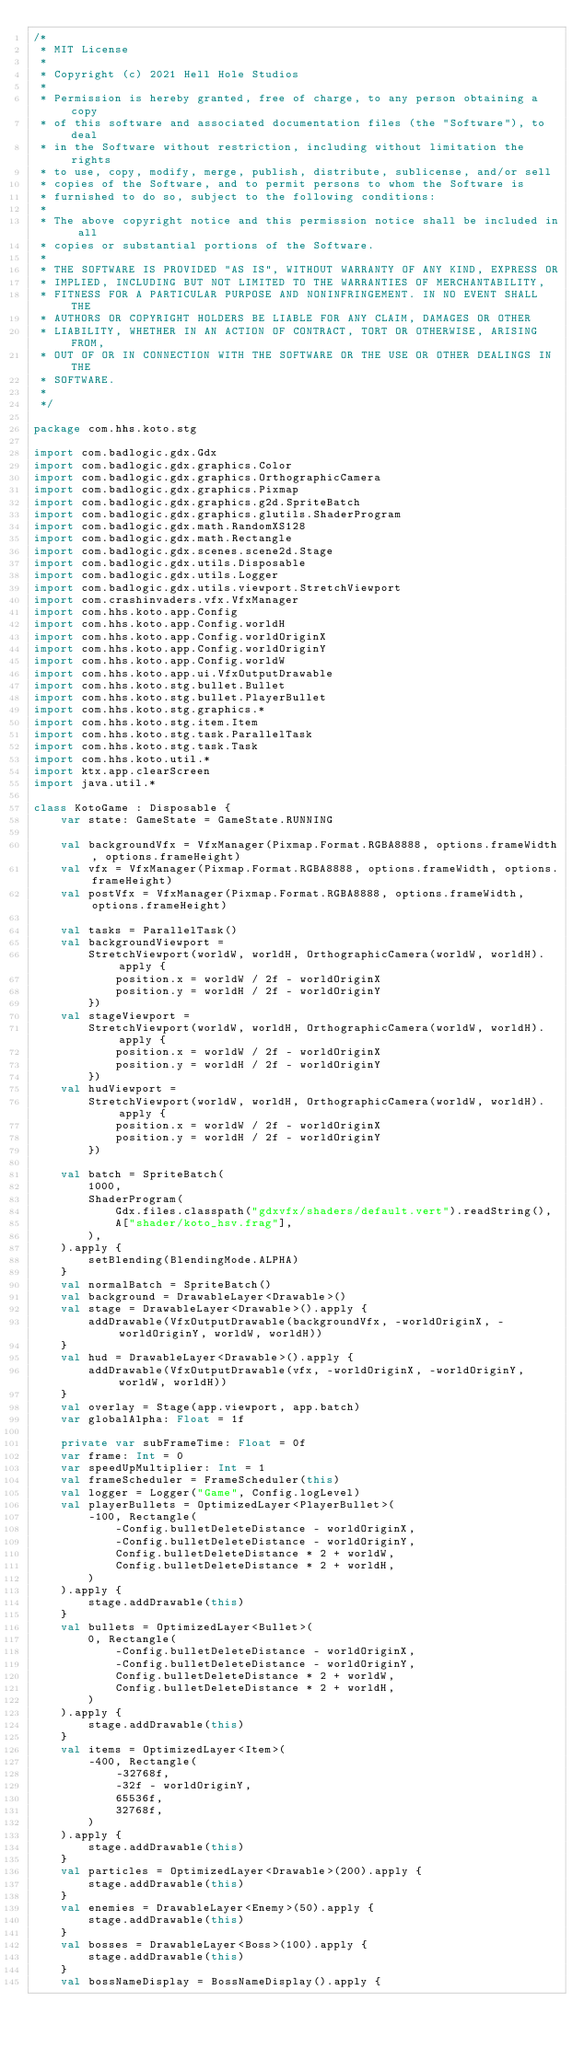<code> <loc_0><loc_0><loc_500><loc_500><_Kotlin_>/*
 * MIT License
 *
 * Copyright (c) 2021 Hell Hole Studios
 *
 * Permission is hereby granted, free of charge, to any person obtaining a copy
 * of this software and associated documentation files (the "Software"), to deal
 * in the Software without restriction, including without limitation the rights
 * to use, copy, modify, merge, publish, distribute, sublicense, and/or sell
 * copies of the Software, and to permit persons to whom the Software is
 * furnished to do so, subject to the following conditions:
 *
 * The above copyright notice and this permission notice shall be included in all
 * copies or substantial portions of the Software.
 *
 * THE SOFTWARE IS PROVIDED "AS IS", WITHOUT WARRANTY OF ANY KIND, EXPRESS OR
 * IMPLIED, INCLUDING BUT NOT LIMITED TO THE WARRANTIES OF MERCHANTABILITY,
 * FITNESS FOR A PARTICULAR PURPOSE AND NONINFRINGEMENT. IN NO EVENT SHALL THE
 * AUTHORS OR COPYRIGHT HOLDERS BE LIABLE FOR ANY CLAIM, DAMAGES OR OTHER
 * LIABILITY, WHETHER IN AN ACTION OF CONTRACT, TORT OR OTHERWISE, ARISING FROM,
 * OUT OF OR IN CONNECTION WITH THE SOFTWARE OR THE USE OR OTHER DEALINGS IN THE
 * SOFTWARE.
 *
 */

package com.hhs.koto.stg

import com.badlogic.gdx.Gdx
import com.badlogic.gdx.graphics.Color
import com.badlogic.gdx.graphics.OrthographicCamera
import com.badlogic.gdx.graphics.Pixmap
import com.badlogic.gdx.graphics.g2d.SpriteBatch
import com.badlogic.gdx.graphics.glutils.ShaderProgram
import com.badlogic.gdx.math.RandomXS128
import com.badlogic.gdx.math.Rectangle
import com.badlogic.gdx.scenes.scene2d.Stage
import com.badlogic.gdx.utils.Disposable
import com.badlogic.gdx.utils.Logger
import com.badlogic.gdx.utils.viewport.StretchViewport
import com.crashinvaders.vfx.VfxManager
import com.hhs.koto.app.Config
import com.hhs.koto.app.Config.worldH
import com.hhs.koto.app.Config.worldOriginX
import com.hhs.koto.app.Config.worldOriginY
import com.hhs.koto.app.Config.worldW
import com.hhs.koto.app.ui.VfxOutputDrawable
import com.hhs.koto.stg.bullet.Bullet
import com.hhs.koto.stg.bullet.PlayerBullet
import com.hhs.koto.stg.graphics.*
import com.hhs.koto.stg.item.Item
import com.hhs.koto.stg.task.ParallelTask
import com.hhs.koto.stg.task.Task
import com.hhs.koto.util.*
import ktx.app.clearScreen
import java.util.*

class KotoGame : Disposable {
    var state: GameState = GameState.RUNNING

    val backgroundVfx = VfxManager(Pixmap.Format.RGBA8888, options.frameWidth, options.frameHeight)
    val vfx = VfxManager(Pixmap.Format.RGBA8888, options.frameWidth, options.frameHeight)
    val postVfx = VfxManager(Pixmap.Format.RGBA8888, options.frameWidth, options.frameHeight)

    val tasks = ParallelTask()
    val backgroundViewport =
        StretchViewport(worldW, worldH, OrthographicCamera(worldW, worldH).apply {
            position.x = worldW / 2f - worldOriginX
            position.y = worldH / 2f - worldOriginY
        })
    val stageViewport =
        StretchViewport(worldW, worldH, OrthographicCamera(worldW, worldH).apply {
            position.x = worldW / 2f - worldOriginX
            position.y = worldH / 2f - worldOriginY
        })
    val hudViewport =
        StretchViewport(worldW, worldH, OrthographicCamera(worldW, worldH).apply {
            position.x = worldW / 2f - worldOriginX
            position.y = worldH / 2f - worldOriginY
        })

    val batch = SpriteBatch(
        1000,
        ShaderProgram(
            Gdx.files.classpath("gdxvfx/shaders/default.vert").readString(),
            A["shader/koto_hsv.frag"],
        ),
    ).apply {
        setBlending(BlendingMode.ALPHA)
    }
    val normalBatch = SpriteBatch()
    val background = DrawableLayer<Drawable>()
    val stage = DrawableLayer<Drawable>().apply {
        addDrawable(VfxOutputDrawable(backgroundVfx, -worldOriginX, -worldOriginY, worldW, worldH))
    }
    val hud = DrawableLayer<Drawable>().apply {
        addDrawable(VfxOutputDrawable(vfx, -worldOriginX, -worldOriginY, worldW, worldH))
    }
    val overlay = Stage(app.viewport, app.batch)
    var globalAlpha: Float = 1f

    private var subFrameTime: Float = 0f
    var frame: Int = 0
    var speedUpMultiplier: Int = 1
    val frameScheduler = FrameScheduler(this)
    val logger = Logger("Game", Config.logLevel)
    val playerBullets = OptimizedLayer<PlayerBullet>(
        -100, Rectangle(
            -Config.bulletDeleteDistance - worldOriginX,
            -Config.bulletDeleteDistance - worldOriginY,
            Config.bulletDeleteDistance * 2 + worldW,
            Config.bulletDeleteDistance * 2 + worldH,
        )
    ).apply {
        stage.addDrawable(this)
    }
    val bullets = OptimizedLayer<Bullet>(
        0, Rectangle(
            -Config.bulletDeleteDistance - worldOriginX,
            -Config.bulletDeleteDistance - worldOriginY,
            Config.bulletDeleteDistance * 2 + worldW,
            Config.bulletDeleteDistance * 2 + worldH,
        )
    ).apply {
        stage.addDrawable(this)
    }
    val items = OptimizedLayer<Item>(
        -400, Rectangle(
            -32768f,
            -32f - worldOriginY,
            65536f,
            32768f,
        )
    ).apply {
        stage.addDrawable(this)
    }
    val particles = OptimizedLayer<Drawable>(200).apply {
        stage.addDrawable(this)
    }
    val enemies = DrawableLayer<Enemy>(50).apply {
        stage.addDrawable(this)
    }
    val bosses = DrawableLayer<Boss>(100).apply {
        stage.addDrawable(this)
    }
    val bossNameDisplay = BossNameDisplay().apply {</code> 